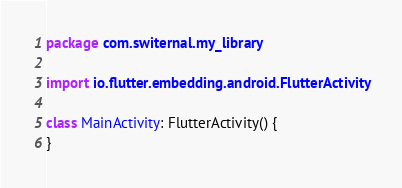Convert code to text. <code><loc_0><loc_0><loc_500><loc_500><_Kotlin_>package com.switernal.my_library

import io.flutter.embedding.android.FlutterActivity

class MainActivity: FlutterActivity() {
}
</code> 